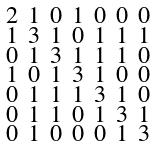Convert formula to latex. <formula><loc_0><loc_0><loc_500><loc_500>\begin{smallmatrix} 2 & 1 & 0 & 1 & 0 & 0 & 0 \\ 1 & 3 & 1 & 0 & 1 & 1 & 1 \\ 0 & 1 & 3 & 1 & 1 & 1 & 0 \\ 1 & 0 & 1 & 3 & 1 & 0 & 0 \\ 0 & 1 & 1 & 1 & 3 & 1 & 0 \\ 0 & 1 & 1 & 0 & 1 & 3 & 1 \\ 0 & 1 & 0 & 0 & 0 & 1 & 3 \end{smallmatrix}</formula> 